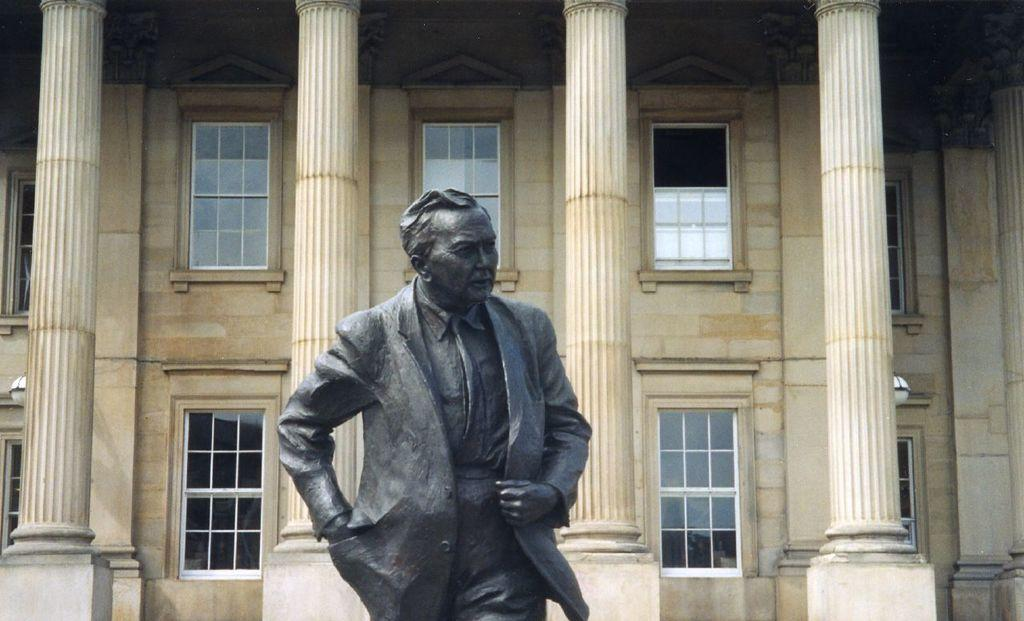What is the main subject of the image? There is a statue of a man in the image. What can be seen in the background of the image? There are pillars and windows in the background of the image. What type of wax is used to create the note on the statue's hand in the image? There is no note or wax present on the statue's hand in the image. What type of cast is visible on the statue's leg in the image? There is no cast visible on the statue's leg in the image. 